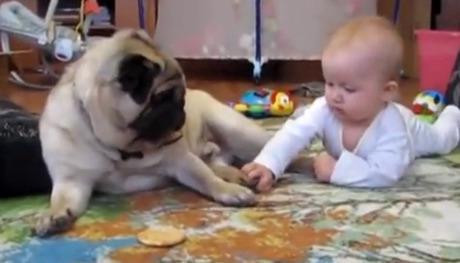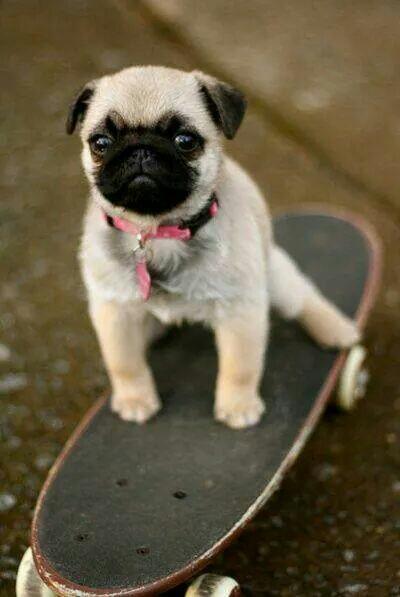The first image is the image on the left, the second image is the image on the right. Considering the images on both sides, is "An image shows exactly one pug dog, which is facing another living creature that is not a pug." valid? Answer yes or no. Yes. The first image is the image on the left, the second image is the image on the right. Analyze the images presented: Is the assertion "At least one person is with the dogs outside in one of the images." valid? Answer yes or no. No. 